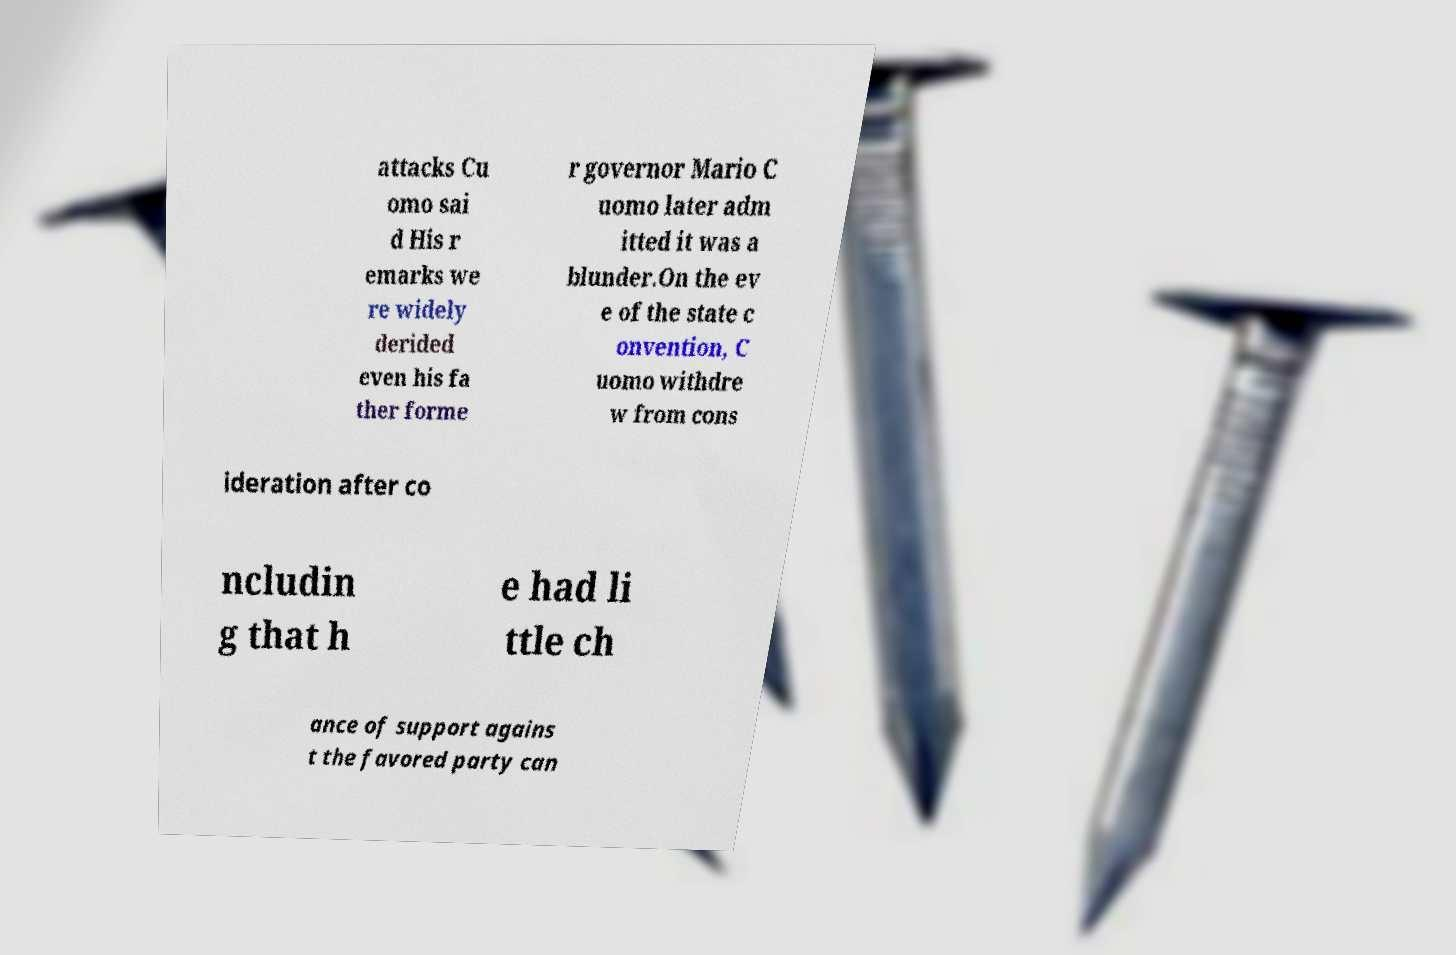What messages or text are displayed in this image? I need them in a readable, typed format. attacks Cu omo sai d His r emarks we re widely derided even his fa ther forme r governor Mario C uomo later adm itted it was a blunder.On the ev e of the state c onvention, C uomo withdre w from cons ideration after co ncludin g that h e had li ttle ch ance of support agains t the favored party can 